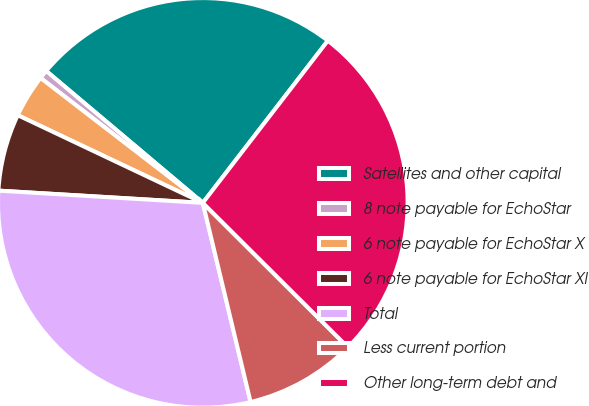Convert chart. <chart><loc_0><loc_0><loc_500><loc_500><pie_chart><fcel>Satellites and other capital<fcel>8 note payable for EchoStar<fcel>6 note payable for EchoStar X<fcel>6 note payable for EchoStar XI<fcel>Total<fcel>Less current portion<fcel>Other long-term debt and<nl><fcel>24.31%<fcel>0.7%<fcel>3.4%<fcel>6.09%<fcel>29.7%<fcel>8.79%<fcel>27.01%<nl></chart> 